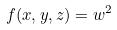<formula> <loc_0><loc_0><loc_500><loc_500>f ( x , y , z ) = w ^ { 2 }</formula> 